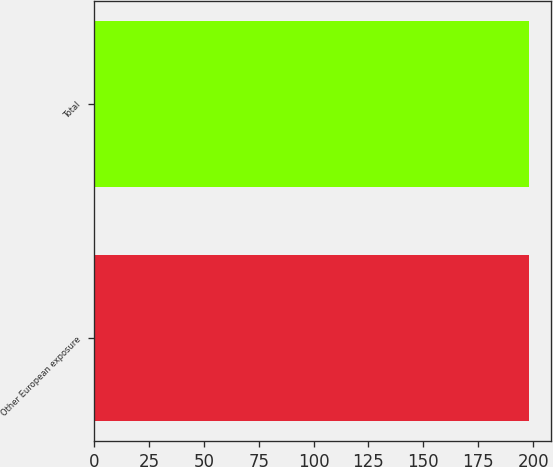Convert chart. <chart><loc_0><loc_0><loc_500><loc_500><bar_chart><fcel>Other European exposure<fcel>Total<nl><fcel>198<fcel>198.1<nl></chart> 